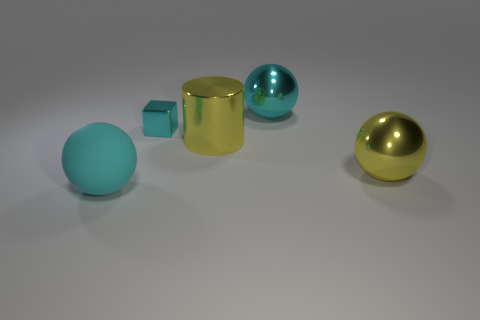Add 2 big yellow cylinders. How many objects exist? 7 Subtract all cubes. How many objects are left? 4 Subtract 0 brown balls. How many objects are left? 5 Subtract all big yellow metal cylinders. Subtract all cyan balls. How many objects are left? 2 Add 1 small cyan metallic things. How many small cyan metallic things are left? 2 Add 1 tiny cyan cubes. How many tiny cyan cubes exist? 2 